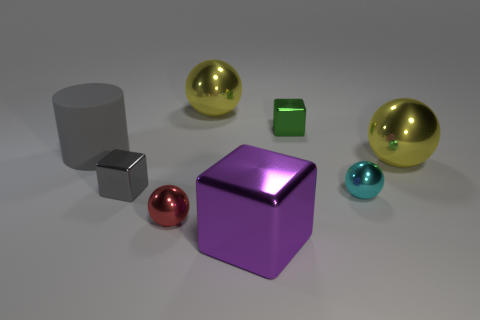Subtract all cyan balls. How many balls are left? 3 Subtract all yellow cylinders. How many yellow balls are left? 2 Add 1 gray cubes. How many objects exist? 9 Subtract all red balls. How many balls are left? 3 Subtract 3 spheres. How many spheres are left? 1 Subtract all blocks. How many objects are left? 5 Subtract all brown balls. Subtract all yellow cylinders. How many balls are left? 4 Subtract all big balls. Subtract all gray cylinders. How many objects are left? 5 Add 7 cyan spheres. How many cyan spheres are left? 8 Add 7 yellow metal objects. How many yellow metal objects exist? 9 